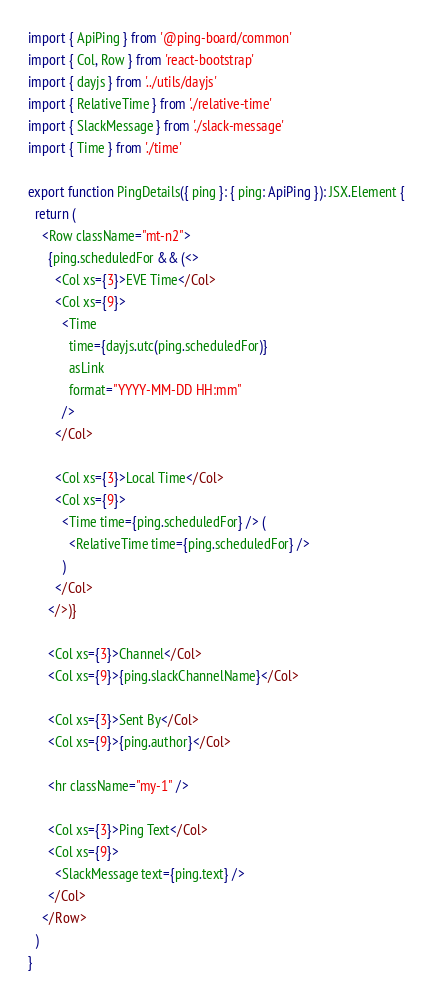<code> <loc_0><loc_0><loc_500><loc_500><_TypeScript_>import { ApiPing } from '@ping-board/common'
import { Col, Row } from 'react-bootstrap'
import { dayjs } from '../utils/dayjs'
import { RelativeTime } from './relative-time'
import { SlackMessage } from './slack-message'
import { Time } from './time'

export function PingDetails({ ping }: { ping: ApiPing }): JSX.Element {
  return (
    <Row className="mt-n2">
      {ping.scheduledFor && (<>
        <Col xs={3}>EVE Time</Col>
        <Col xs={9}>
          <Time
            time={dayjs.utc(ping.scheduledFor)}
            asLink
            format="YYYY-MM-DD HH:mm"
          />
        </Col>

        <Col xs={3}>Local Time</Col>
        <Col xs={9}>
          <Time time={ping.scheduledFor} /> (
            <RelativeTime time={ping.scheduledFor} />
          )
        </Col>
      </>)}

      <Col xs={3}>Channel</Col>
      <Col xs={9}>{ping.slackChannelName}</Col>

      <Col xs={3}>Sent By</Col>
      <Col xs={9}>{ping.author}</Col>

      <hr className="my-1" />

      <Col xs={3}>Ping Text</Col>
      <Col xs={9}>
        <SlackMessage text={ping.text} />
      </Col>
    </Row>
  )
}
</code> 